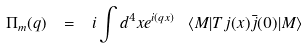Convert formula to latex. <formula><loc_0><loc_0><loc_500><loc_500>\Pi _ { m } ( q ) \ = \ i \int d ^ { 4 } x e ^ { i ( q x ) } \ \langle M | T j ( x ) \bar { j } ( 0 ) | M \rangle</formula> 